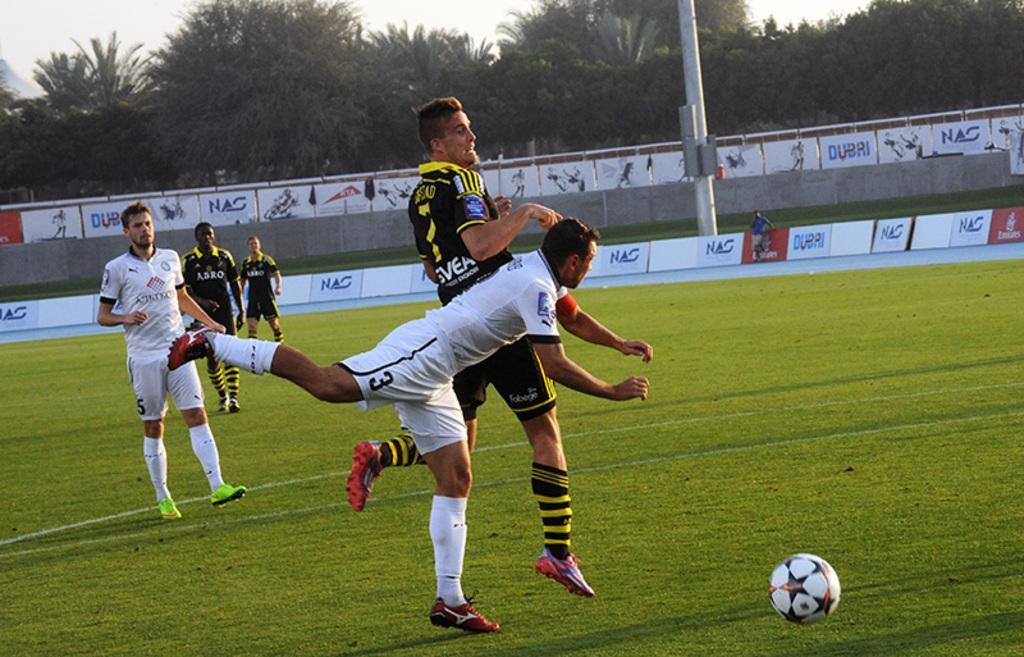Describe this image in one or two sentences. In this image people are playing football on surface of the ground. At the back side there are trees. 